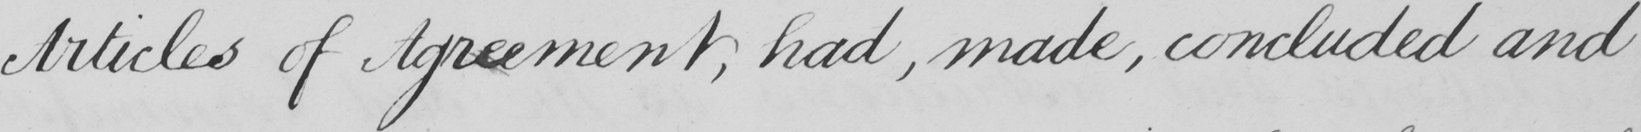What text is written in this handwritten line? Articles of Agreement , had , made , concluded and 